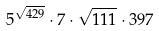Convert formula to latex. <formula><loc_0><loc_0><loc_500><loc_500>5 ^ { \sqrt { 4 2 9 } } \cdot 7 \cdot \sqrt { 1 1 1 } \cdot 3 9 7</formula> 